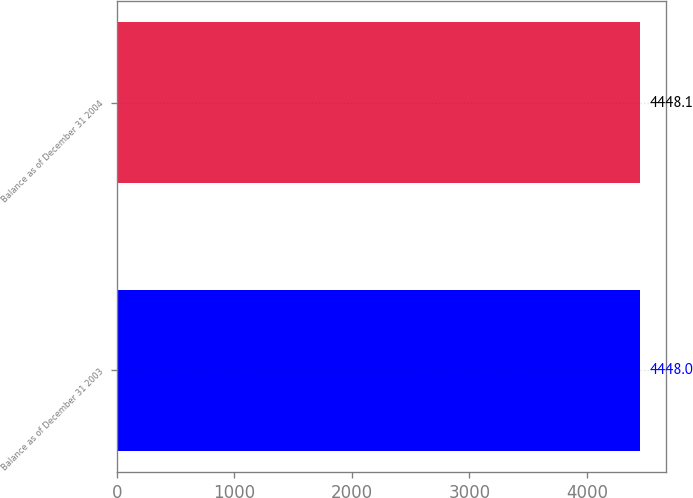Convert chart. <chart><loc_0><loc_0><loc_500><loc_500><bar_chart><fcel>Balance as of December 31 2003<fcel>Balance as of December 31 2004<nl><fcel>4448<fcel>4448.1<nl></chart> 